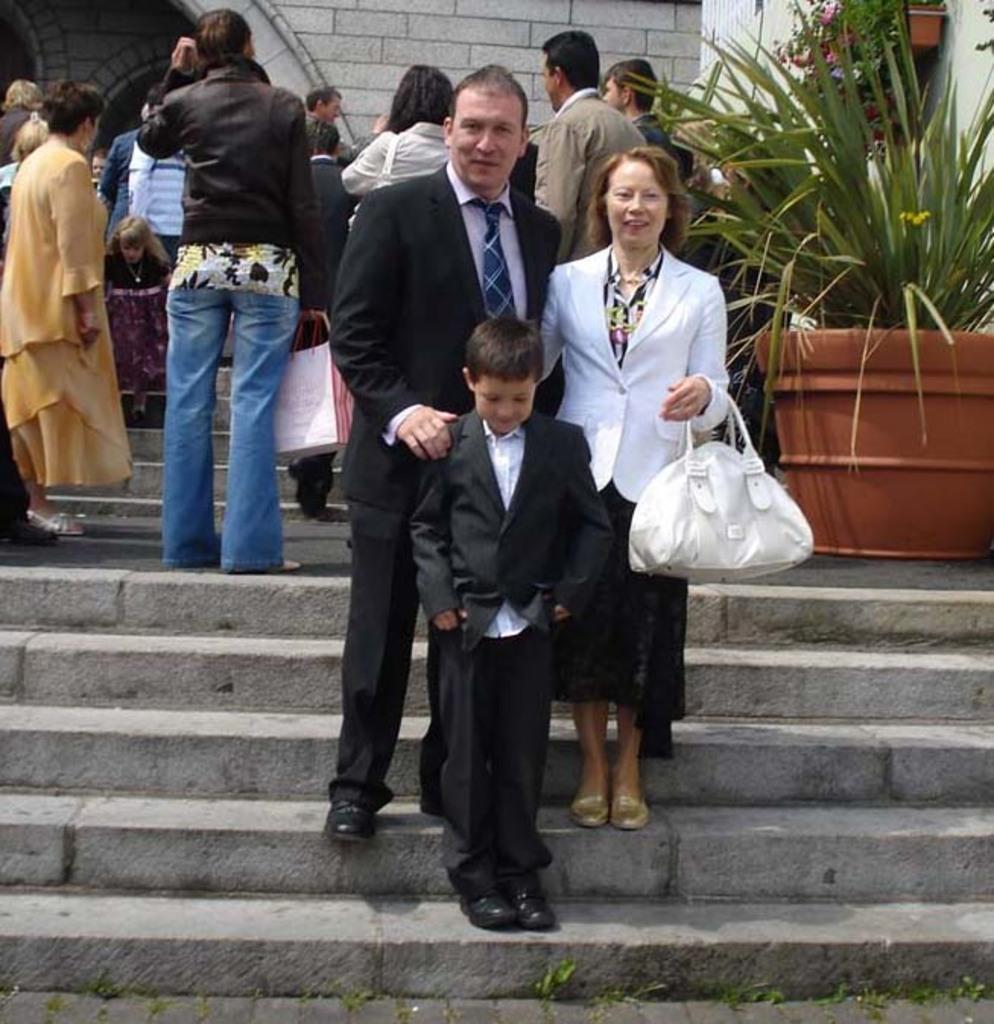Please provide a concise description of this image. In this image I see a man and a woman and both of them are smiling, I can also see a child over here and they are on the steps. In the background I see few people and a plant. 